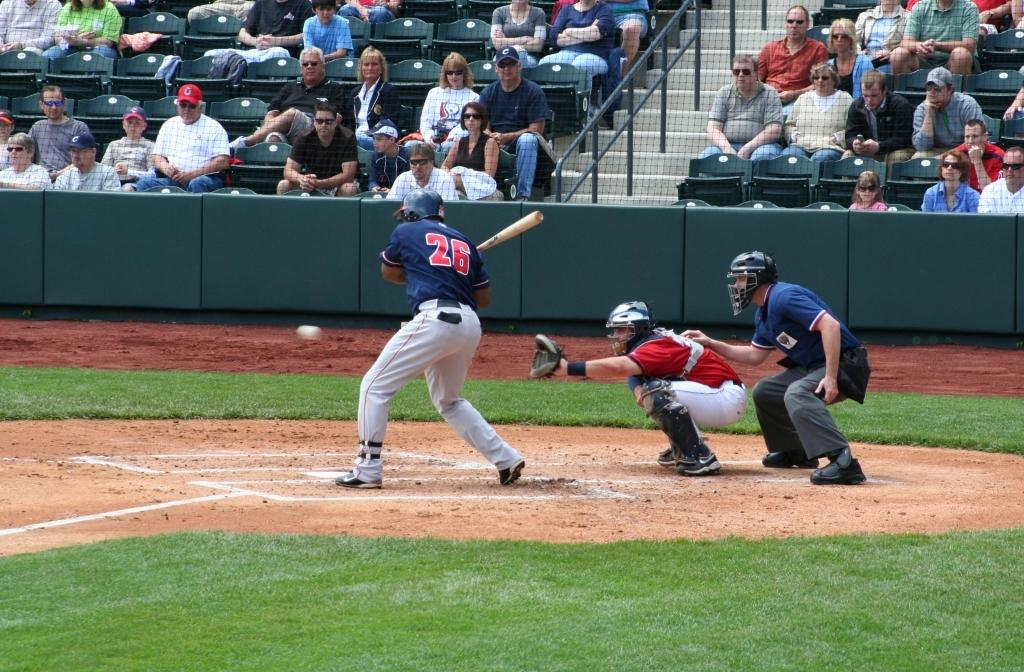<image>
Summarize the visual content of the image. Baseball player number 26 gets ready to hit the ball. 